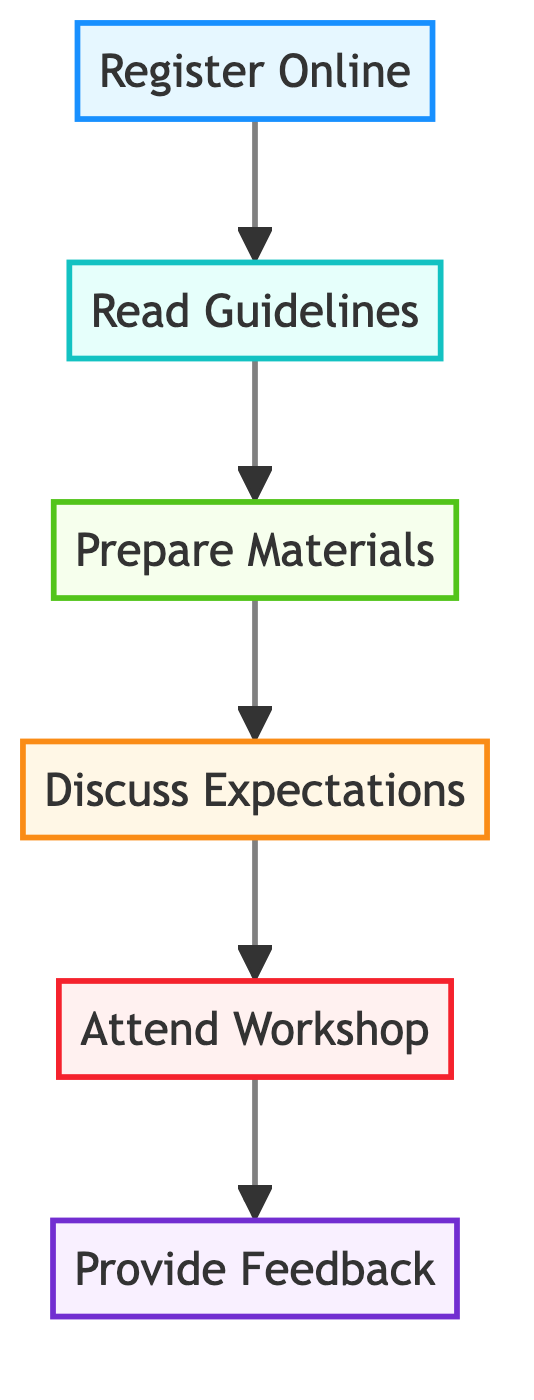What is the first step in the preparation process? The first step is indicated at the bottom of the flow chart, which shows "Register Online" as the initial action to take before progressing to subsequent steps.
Answer: Register Online How many total steps are there in the workshop preparation? By counting the nodes in the diagram, there are six steps represented from bottom to top: Register Online, Read Guidelines, Prepare Materials, Discuss Expectations, Attend Workshop, and Provide Feedback.
Answer: Six What step comes after "Prepare Materials"? The flow chart explicitly shows that the next step following "Prepare Materials" is "Discuss Expectations," indicated by the upward arrow leading to that node.
Answer: Discuss Expectations What is the final action to take once the workshop is completed? The top node indicates the last action to take after the workshop, which is to "Provide Feedback," as the last step in the preparation process.
Answer: Provide Feedback How are "Attend Workshop" and "Register Online" connected? The diagram depicts a direct flow from "Register Online" at the bottom to "Attend Workshop" further up, indicating that registering online is a prerequisite for attending the workshop.
Answer: Through "Read Guidelines," "Prepare Materials," and "Discuss Expectations." What does "Read Guidelines" involve? The description for "Read Guidelines" includes reviewing essential information such as safety protocols and inclusivity statements, indicating that this step is crucial for understanding the event's standards.
Answer: Reviewing safety protocols and inclusivity statements Which step emphasizes communication with the child? The step labeled "Discuss Expectations" specifically highlights the need for parents to communicate with their children regarding workshop expectations, fostering a sense of preparedness and involvement.
Answer: Discuss Expectations In which step must you arrive early? The description under "Attend Workshop" mentions arriving early to check in at the venue, highlighting the importance of this step for participation in the event.
Answer: Attend Workshop 